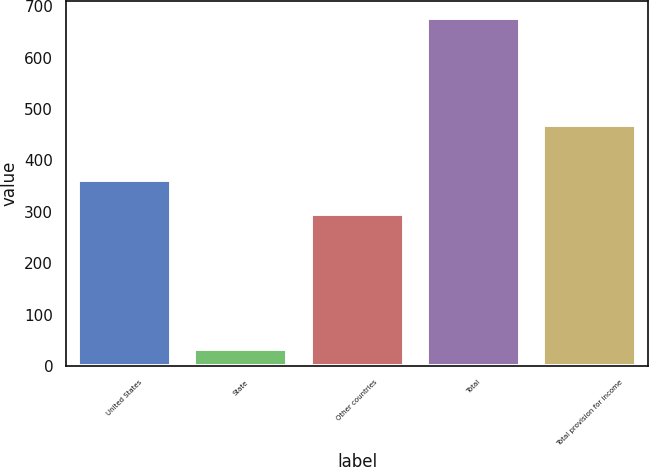<chart> <loc_0><loc_0><loc_500><loc_500><bar_chart><fcel>United States<fcel>State<fcel>Other countries<fcel>Total<fcel>Total provision for income<nl><fcel>361.04<fcel>32.8<fcel>296.6<fcel>677.2<fcel>469.2<nl></chart> 